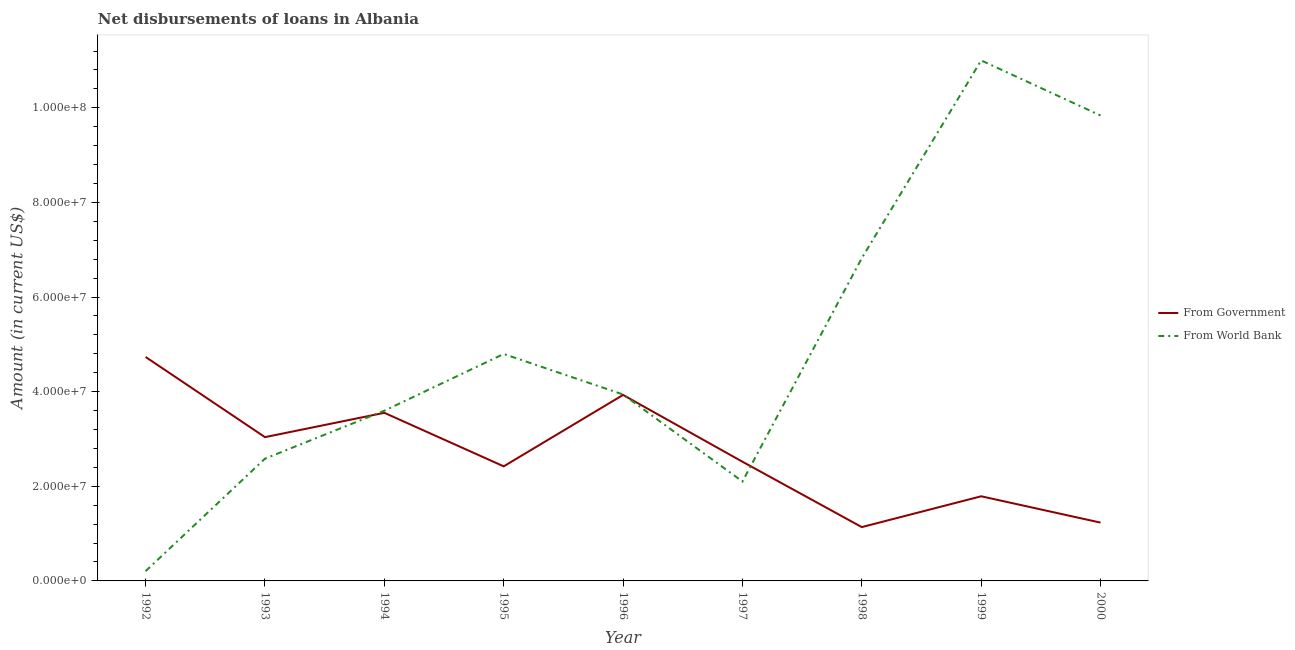What is the net disbursements of loan from government in 1995?
Your answer should be compact. 2.42e+07. Across all years, what is the maximum net disbursements of loan from government?
Ensure brevity in your answer.  4.73e+07. Across all years, what is the minimum net disbursements of loan from world bank?
Make the answer very short. 2.06e+06. In which year was the net disbursements of loan from government maximum?
Provide a short and direct response. 1992. In which year was the net disbursements of loan from world bank minimum?
Provide a short and direct response. 1992. What is the total net disbursements of loan from government in the graph?
Your answer should be very brief. 2.44e+08. What is the difference between the net disbursements of loan from world bank in 1992 and that in 1999?
Your answer should be compact. -1.08e+08. What is the difference between the net disbursements of loan from government in 1994 and the net disbursements of loan from world bank in 1998?
Offer a terse response. -3.27e+07. What is the average net disbursements of loan from world bank per year?
Ensure brevity in your answer.  4.99e+07. In the year 1992, what is the difference between the net disbursements of loan from government and net disbursements of loan from world bank?
Ensure brevity in your answer.  4.53e+07. In how many years, is the net disbursements of loan from world bank greater than 84000000 US$?
Make the answer very short. 2. What is the ratio of the net disbursements of loan from world bank in 1998 to that in 2000?
Ensure brevity in your answer.  0.69. What is the difference between the highest and the second highest net disbursements of loan from world bank?
Ensure brevity in your answer.  1.16e+07. What is the difference between the highest and the lowest net disbursements of loan from government?
Provide a succinct answer. 3.60e+07. In how many years, is the net disbursements of loan from government greater than the average net disbursements of loan from government taken over all years?
Make the answer very short. 4. Does the net disbursements of loan from world bank monotonically increase over the years?
Make the answer very short. No. Is the net disbursements of loan from government strictly less than the net disbursements of loan from world bank over the years?
Ensure brevity in your answer.  No. How many lines are there?
Your answer should be compact. 2. Are the values on the major ticks of Y-axis written in scientific E-notation?
Your response must be concise. Yes. Does the graph contain any zero values?
Your answer should be very brief. No. Does the graph contain grids?
Your answer should be compact. No. What is the title of the graph?
Keep it short and to the point. Net disbursements of loans in Albania. Does "Tetanus" appear as one of the legend labels in the graph?
Give a very brief answer. No. What is the label or title of the X-axis?
Your response must be concise. Year. What is the label or title of the Y-axis?
Make the answer very short. Amount (in current US$). What is the Amount (in current US$) of From Government in 1992?
Offer a terse response. 4.73e+07. What is the Amount (in current US$) in From World Bank in 1992?
Your response must be concise. 2.06e+06. What is the Amount (in current US$) in From Government in 1993?
Provide a short and direct response. 3.04e+07. What is the Amount (in current US$) of From World Bank in 1993?
Give a very brief answer. 2.58e+07. What is the Amount (in current US$) in From Government in 1994?
Offer a terse response. 3.55e+07. What is the Amount (in current US$) in From World Bank in 1994?
Give a very brief answer. 3.60e+07. What is the Amount (in current US$) of From Government in 1995?
Keep it short and to the point. 2.42e+07. What is the Amount (in current US$) in From World Bank in 1995?
Your response must be concise. 4.80e+07. What is the Amount (in current US$) in From Government in 1996?
Your answer should be compact. 3.93e+07. What is the Amount (in current US$) in From World Bank in 1996?
Your response must be concise. 3.94e+07. What is the Amount (in current US$) in From Government in 1997?
Make the answer very short. 2.52e+07. What is the Amount (in current US$) in From World Bank in 1997?
Ensure brevity in your answer.  2.10e+07. What is the Amount (in current US$) of From Government in 1998?
Provide a succinct answer. 1.14e+07. What is the Amount (in current US$) of From World Bank in 1998?
Your answer should be very brief. 6.82e+07. What is the Amount (in current US$) in From Government in 1999?
Keep it short and to the point. 1.79e+07. What is the Amount (in current US$) in From World Bank in 1999?
Your response must be concise. 1.10e+08. What is the Amount (in current US$) of From Government in 2000?
Ensure brevity in your answer.  1.23e+07. What is the Amount (in current US$) in From World Bank in 2000?
Offer a terse response. 9.84e+07. Across all years, what is the maximum Amount (in current US$) in From Government?
Provide a short and direct response. 4.73e+07. Across all years, what is the maximum Amount (in current US$) of From World Bank?
Make the answer very short. 1.10e+08. Across all years, what is the minimum Amount (in current US$) of From Government?
Make the answer very short. 1.14e+07. Across all years, what is the minimum Amount (in current US$) in From World Bank?
Give a very brief answer. 2.06e+06. What is the total Amount (in current US$) of From Government in the graph?
Provide a succinct answer. 2.44e+08. What is the total Amount (in current US$) of From World Bank in the graph?
Keep it short and to the point. 4.49e+08. What is the difference between the Amount (in current US$) in From Government in 1992 and that in 1993?
Ensure brevity in your answer.  1.69e+07. What is the difference between the Amount (in current US$) in From World Bank in 1992 and that in 1993?
Offer a terse response. -2.38e+07. What is the difference between the Amount (in current US$) of From Government in 1992 and that in 1994?
Give a very brief answer. 1.18e+07. What is the difference between the Amount (in current US$) of From World Bank in 1992 and that in 1994?
Make the answer very short. -3.39e+07. What is the difference between the Amount (in current US$) in From Government in 1992 and that in 1995?
Provide a succinct answer. 2.31e+07. What is the difference between the Amount (in current US$) in From World Bank in 1992 and that in 1995?
Your answer should be compact. -4.59e+07. What is the difference between the Amount (in current US$) in From Government in 1992 and that in 1996?
Offer a very short reply. 8.02e+06. What is the difference between the Amount (in current US$) of From World Bank in 1992 and that in 1996?
Your response must be concise. -3.73e+07. What is the difference between the Amount (in current US$) in From Government in 1992 and that in 1997?
Your response must be concise. 2.21e+07. What is the difference between the Amount (in current US$) in From World Bank in 1992 and that in 1997?
Make the answer very short. -1.90e+07. What is the difference between the Amount (in current US$) of From Government in 1992 and that in 1998?
Give a very brief answer. 3.60e+07. What is the difference between the Amount (in current US$) of From World Bank in 1992 and that in 1998?
Your response must be concise. -6.62e+07. What is the difference between the Amount (in current US$) of From Government in 1992 and that in 1999?
Make the answer very short. 2.94e+07. What is the difference between the Amount (in current US$) in From World Bank in 1992 and that in 1999?
Keep it short and to the point. -1.08e+08. What is the difference between the Amount (in current US$) in From Government in 1992 and that in 2000?
Provide a succinct answer. 3.50e+07. What is the difference between the Amount (in current US$) of From World Bank in 1992 and that in 2000?
Provide a short and direct response. -9.63e+07. What is the difference between the Amount (in current US$) of From Government in 1993 and that in 1994?
Offer a very short reply. -5.14e+06. What is the difference between the Amount (in current US$) of From World Bank in 1993 and that in 1994?
Offer a terse response. -1.01e+07. What is the difference between the Amount (in current US$) of From Government in 1993 and that in 1995?
Offer a terse response. 6.17e+06. What is the difference between the Amount (in current US$) of From World Bank in 1993 and that in 1995?
Your response must be concise. -2.21e+07. What is the difference between the Amount (in current US$) in From Government in 1993 and that in 1996?
Offer a very short reply. -8.92e+06. What is the difference between the Amount (in current US$) of From World Bank in 1993 and that in 1996?
Your answer should be very brief. -1.36e+07. What is the difference between the Amount (in current US$) of From Government in 1993 and that in 1997?
Your answer should be very brief. 5.19e+06. What is the difference between the Amount (in current US$) in From World Bank in 1993 and that in 1997?
Keep it short and to the point. 4.82e+06. What is the difference between the Amount (in current US$) in From Government in 1993 and that in 1998?
Make the answer very short. 1.90e+07. What is the difference between the Amount (in current US$) in From World Bank in 1993 and that in 1998?
Give a very brief answer. -4.24e+07. What is the difference between the Amount (in current US$) of From Government in 1993 and that in 1999?
Offer a very short reply. 1.25e+07. What is the difference between the Amount (in current US$) in From World Bank in 1993 and that in 1999?
Provide a succinct answer. -8.42e+07. What is the difference between the Amount (in current US$) in From Government in 1993 and that in 2000?
Your response must be concise. 1.81e+07. What is the difference between the Amount (in current US$) in From World Bank in 1993 and that in 2000?
Ensure brevity in your answer.  -7.25e+07. What is the difference between the Amount (in current US$) in From Government in 1994 and that in 1995?
Offer a very short reply. 1.13e+07. What is the difference between the Amount (in current US$) in From World Bank in 1994 and that in 1995?
Provide a short and direct response. -1.20e+07. What is the difference between the Amount (in current US$) in From Government in 1994 and that in 1996?
Your answer should be very brief. -3.78e+06. What is the difference between the Amount (in current US$) in From World Bank in 1994 and that in 1996?
Keep it short and to the point. -3.43e+06. What is the difference between the Amount (in current US$) of From Government in 1994 and that in 1997?
Keep it short and to the point. 1.03e+07. What is the difference between the Amount (in current US$) in From World Bank in 1994 and that in 1997?
Make the answer very short. 1.50e+07. What is the difference between the Amount (in current US$) of From Government in 1994 and that in 1998?
Give a very brief answer. 2.42e+07. What is the difference between the Amount (in current US$) in From World Bank in 1994 and that in 1998?
Ensure brevity in your answer.  -3.23e+07. What is the difference between the Amount (in current US$) in From Government in 1994 and that in 1999?
Your response must be concise. 1.76e+07. What is the difference between the Amount (in current US$) in From World Bank in 1994 and that in 1999?
Give a very brief answer. -7.40e+07. What is the difference between the Amount (in current US$) in From Government in 1994 and that in 2000?
Give a very brief answer. 2.32e+07. What is the difference between the Amount (in current US$) of From World Bank in 1994 and that in 2000?
Provide a short and direct response. -6.24e+07. What is the difference between the Amount (in current US$) of From Government in 1995 and that in 1996?
Provide a succinct answer. -1.51e+07. What is the difference between the Amount (in current US$) of From World Bank in 1995 and that in 1996?
Offer a very short reply. 8.56e+06. What is the difference between the Amount (in current US$) in From Government in 1995 and that in 1997?
Your answer should be compact. -9.78e+05. What is the difference between the Amount (in current US$) of From World Bank in 1995 and that in 1997?
Offer a terse response. 2.70e+07. What is the difference between the Amount (in current US$) of From Government in 1995 and that in 1998?
Offer a very short reply. 1.28e+07. What is the difference between the Amount (in current US$) in From World Bank in 1995 and that in 1998?
Keep it short and to the point. -2.03e+07. What is the difference between the Amount (in current US$) of From Government in 1995 and that in 1999?
Your answer should be compact. 6.33e+06. What is the difference between the Amount (in current US$) of From World Bank in 1995 and that in 1999?
Your answer should be very brief. -6.20e+07. What is the difference between the Amount (in current US$) in From Government in 1995 and that in 2000?
Provide a succinct answer. 1.19e+07. What is the difference between the Amount (in current US$) of From World Bank in 1995 and that in 2000?
Give a very brief answer. -5.04e+07. What is the difference between the Amount (in current US$) of From Government in 1996 and that in 1997?
Provide a succinct answer. 1.41e+07. What is the difference between the Amount (in current US$) of From World Bank in 1996 and that in 1997?
Provide a succinct answer. 1.84e+07. What is the difference between the Amount (in current US$) in From Government in 1996 and that in 1998?
Provide a short and direct response. 2.79e+07. What is the difference between the Amount (in current US$) of From World Bank in 1996 and that in 1998?
Keep it short and to the point. -2.88e+07. What is the difference between the Amount (in current US$) of From Government in 1996 and that in 1999?
Offer a terse response. 2.14e+07. What is the difference between the Amount (in current US$) of From World Bank in 1996 and that in 1999?
Offer a very short reply. -7.06e+07. What is the difference between the Amount (in current US$) in From Government in 1996 and that in 2000?
Your response must be concise. 2.70e+07. What is the difference between the Amount (in current US$) in From World Bank in 1996 and that in 2000?
Make the answer very short. -5.90e+07. What is the difference between the Amount (in current US$) in From Government in 1997 and that in 1998?
Your response must be concise. 1.38e+07. What is the difference between the Amount (in current US$) in From World Bank in 1997 and that in 1998?
Your answer should be compact. -4.72e+07. What is the difference between the Amount (in current US$) of From Government in 1997 and that in 1999?
Your answer should be very brief. 7.31e+06. What is the difference between the Amount (in current US$) of From World Bank in 1997 and that in 1999?
Give a very brief answer. -8.90e+07. What is the difference between the Amount (in current US$) of From Government in 1997 and that in 2000?
Provide a succinct answer. 1.29e+07. What is the difference between the Amount (in current US$) of From World Bank in 1997 and that in 2000?
Offer a very short reply. -7.74e+07. What is the difference between the Amount (in current US$) in From Government in 1998 and that in 1999?
Offer a terse response. -6.52e+06. What is the difference between the Amount (in current US$) of From World Bank in 1998 and that in 1999?
Keep it short and to the point. -4.18e+07. What is the difference between the Amount (in current US$) of From Government in 1998 and that in 2000?
Offer a terse response. -9.48e+05. What is the difference between the Amount (in current US$) of From World Bank in 1998 and that in 2000?
Your answer should be compact. -3.01e+07. What is the difference between the Amount (in current US$) of From Government in 1999 and that in 2000?
Make the answer very short. 5.57e+06. What is the difference between the Amount (in current US$) of From World Bank in 1999 and that in 2000?
Offer a very short reply. 1.16e+07. What is the difference between the Amount (in current US$) of From Government in 1992 and the Amount (in current US$) of From World Bank in 1993?
Keep it short and to the point. 2.15e+07. What is the difference between the Amount (in current US$) in From Government in 1992 and the Amount (in current US$) in From World Bank in 1994?
Your answer should be compact. 1.14e+07. What is the difference between the Amount (in current US$) of From Government in 1992 and the Amount (in current US$) of From World Bank in 1995?
Your answer should be very brief. -6.33e+05. What is the difference between the Amount (in current US$) in From Government in 1992 and the Amount (in current US$) in From World Bank in 1996?
Offer a terse response. 7.93e+06. What is the difference between the Amount (in current US$) of From Government in 1992 and the Amount (in current US$) of From World Bank in 1997?
Your answer should be very brief. 2.63e+07. What is the difference between the Amount (in current US$) of From Government in 1992 and the Amount (in current US$) of From World Bank in 1998?
Give a very brief answer. -2.09e+07. What is the difference between the Amount (in current US$) of From Government in 1992 and the Amount (in current US$) of From World Bank in 1999?
Your answer should be very brief. -6.27e+07. What is the difference between the Amount (in current US$) in From Government in 1992 and the Amount (in current US$) in From World Bank in 2000?
Provide a short and direct response. -5.10e+07. What is the difference between the Amount (in current US$) in From Government in 1993 and the Amount (in current US$) in From World Bank in 1994?
Ensure brevity in your answer.  -5.58e+06. What is the difference between the Amount (in current US$) in From Government in 1993 and the Amount (in current US$) in From World Bank in 1995?
Keep it short and to the point. -1.76e+07. What is the difference between the Amount (in current US$) in From Government in 1993 and the Amount (in current US$) in From World Bank in 1996?
Keep it short and to the point. -9.02e+06. What is the difference between the Amount (in current US$) of From Government in 1993 and the Amount (in current US$) of From World Bank in 1997?
Offer a very short reply. 9.38e+06. What is the difference between the Amount (in current US$) in From Government in 1993 and the Amount (in current US$) in From World Bank in 1998?
Offer a very short reply. -3.78e+07. What is the difference between the Amount (in current US$) of From Government in 1993 and the Amount (in current US$) of From World Bank in 1999?
Make the answer very short. -7.96e+07. What is the difference between the Amount (in current US$) of From Government in 1993 and the Amount (in current US$) of From World Bank in 2000?
Provide a short and direct response. -6.80e+07. What is the difference between the Amount (in current US$) in From Government in 1994 and the Amount (in current US$) in From World Bank in 1995?
Keep it short and to the point. -1.24e+07. What is the difference between the Amount (in current US$) of From Government in 1994 and the Amount (in current US$) of From World Bank in 1996?
Ensure brevity in your answer.  -3.88e+06. What is the difference between the Amount (in current US$) of From Government in 1994 and the Amount (in current US$) of From World Bank in 1997?
Give a very brief answer. 1.45e+07. What is the difference between the Amount (in current US$) of From Government in 1994 and the Amount (in current US$) of From World Bank in 1998?
Your response must be concise. -3.27e+07. What is the difference between the Amount (in current US$) in From Government in 1994 and the Amount (in current US$) in From World Bank in 1999?
Offer a terse response. -7.45e+07. What is the difference between the Amount (in current US$) of From Government in 1994 and the Amount (in current US$) of From World Bank in 2000?
Keep it short and to the point. -6.28e+07. What is the difference between the Amount (in current US$) of From Government in 1995 and the Amount (in current US$) of From World Bank in 1996?
Offer a very short reply. -1.52e+07. What is the difference between the Amount (in current US$) in From Government in 1995 and the Amount (in current US$) in From World Bank in 1997?
Your answer should be compact. 3.20e+06. What is the difference between the Amount (in current US$) in From Government in 1995 and the Amount (in current US$) in From World Bank in 1998?
Your response must be concise. -4.40e+07. What is the difference between the Amount (in current US$) in From Government in 1995 and the Amount (in current US$) in From World Bank in 1999?
Give a very brief answer. -8.58e+07. What is the difference between the Amount (in current US$) of From Government in 1995 and the Amount (in current US$) of From World Bank in 2000?
Your answer should be compact. -7.42e+07. What is the difference between the Amount (in current US$) of From Government in 1996 and the Amount (in current US$) of From World Bank in 1997?
Offer a terse response. 1.83e+07. What is the difference between the Amount (in current US$) of From Government in 1996 and the Amount (in current US$) of From World Bank in 1998?
Offer a very short reply. -2.89e+07. What is the difference between the Amount (in current US$) in From Government in 1996 and the Amount (in current US$) in From World Bank in 1999?
Your answer should be compact. -7.07e+07. What is the difference between the Amount (in current US$) of From Government in 1996 and the Amount (in current US$) of From World Bank in 2000?
Give a very brief answer. -5.91e+07. What is the difference between the Amount (in current US$) of From Government in 1997 and the Amount (in current US$) of From World Bank in 1998?
Offer a terse response. -4.30e+07. What is the difference between the Amount (in current US$) of From Government in 1997 and the Amount (in current US$) of From World Bank in 1999?
Ensure brevity in your answer.  -8.48e+07. What is the difference between the Amount (in current US$) in From Government in 1997 and the Amount (in current US$) in From World Bank in 2000?
Make the answer very short. -7.32e+07. What is the difference between the Amount (in current US$) of From Government in 1998 and the Amount (in current US$) of From World Bank in 1999?
Keep it short and to the point. -9.86e+07. What is the difference between the Amount (in current US$) in From Government in 1998 and the Amount (in current US$) in From World Bank in 2000?
Your answer should be compact. -8.70e+07. What is the difference between the Amount (in current US$) in From Government in 1999 and the Amount (in current US$) in From World Bank in 2000?
Ensure brevity in your answer.  -8.05e+07. What is the average Amount (in current US$) of From Government per year?
Your response must be concise. 2.71e+07. What is the average Amount (in current US$) of From World Bank per year?
Keep it short and to the point. 4.99e+07. In the year 1992, what is the difference between the Amount (in current US$) in From Government and Amount (in current US$) in From World Bank?
Provide a short and direct response. 4.53e+07. In the year 1993, what is the difference between the Amount (in current US$) of From Government and Amount (in current US$) of From World Bank?
Keep it short and to the point. 4.55e+06. In the year 1994, what is the difference between the Amount (in current US$) of From Government and Amount (in current US$) of From World Bank?
Keep it short and to the point. -4.43e+05. In the year 1995, what is the difference between the Amount (in current US$) of From Government and Amount (in current US$) of From World Bank?
Provide a short and direct response. -2.38e+07. In the year 1996, what is the difference between the Amount (in current US$) of From Government and Amount (in current US$) of From World Bank?
Offer a very short reply. -9.50e+04. In the year 1997, what is the difference between the Amount (in current US$) of From Government and Amount (in current US$) of From World Bank?
Offer a very short reply. 4.18e+06. In the year 1998, what is the difference between the Amount (in current US$) of From Government and Amount (in current US$) of From World Bank?
Offer a terse response. -5.69e+07. In the year 1999, what is the difference between the Amount (in current US$) of From Government and Amount (in current US$) of From World Bank?
Provide a short and direct response. -9.21e+07. In the year 2000, what is the difference between the Amount (in current US$) in From Government and Amount (in current US$) in From World Bank?
Your response must be concise. -8.61e+07. What is the ratio of the Amount (in current US$) in From Government in 1992 to that in 1993?
Ensure brevity in your answer.  1.56. What is the ratio of the Amount (in current US$) of From World Bank in 1992 to that in 1993?
Your answer should be compact. 0.08. What is the ratio of the Amount (in current US$) in From Government in 1992 to that in 1994?
Your answer should be very brief. 1.33. What is the ratio of the Amount (in current US$) in From World Bank in 1992 to that in 1994?
Provide a short and direct response. 0.06. What is the ratio of the Amount (in current US$) in From Government in 1992 to that in 1995?
Your answer should be very brief. 1.95. What is the ratio of the Amount (in current US$) of From World Bank in 1992 to that in 1995?
Offer a terse response. 0.04. What is the ratio of the Amount (in current US$) in From Government in 1992 to that in 1996?
Offer a very short reply. 1.2. What is the ratio of the Amount (in current US$) in From World Bank in 1992 to that in 1996?
Keep it short and to the point. 0.05. What is the ratio of the Amount (in current US$) of From Government in 1992 to that in 1997?
Offer a very short reply. 1.88. What is the ratio of the Amount (in current US$) in From World Bank in 1992 to that in 1997?
Make the answer very short. 0.1. What is the ratio of the Amount (in current US$) in From Government in 1992 to that in 1998?
Your answer should be very brief. 4.16. What is the ratio of the Amount (in current US$) of From World Bank in 1992 to that in 1998?
Keep it short and to the point. 0.03. What is the ratio of the Amount (in current US$) of From Government in 1992 to that in 1999?
Your response must be concise. 2.65. What is the ratio of the Amount (in current US$) of From World Bank in 1992 to that in 1999?
Your response must be concise. 0.02. What is the ratio of the Amount (in current US$) in From Government in 1992 to that in 2000?
Offer a very short reply. 3.84. What is the ratio of the Amount (in current US$) in From World Bank in 1992 to that in 2000?
Your answer should be compact. 0.02. What is the ratio of the Amount (in current US$) in From Government in 1993 to that in 1994?
Your answer should be compact. 0.86. What is the ratio of the Amount (in current US$) of From World Bank in 1993 to that in 1994?
Ensure brevity in your answer.  0.72. What is the ratio of the Amount (in current US$) of From Government in 1993 to that in 1995?
Your answer should be very brief. 1.25. What is the ratio of the Amount (in current US$) of From World Bank in 1993 to that in 1995?
Your response must be concise. 0.54. What is the ratio of the Amount (in current US$) in From Government in 1993 to that in 1996?
Your answer should be very brief. 0.77. What is the ratio of the Amount (in current US$) in From World Bank in 1993 to that in 1996?
Your answer should be compact. 0.66. What is the ratio of the Amount (in current US$) in From Government in 1993 to that in 1997?
Make the answer very short. 1.21. What is the ratio of the Amount (in current US$) of From World Bank in 1993 to that in 1997?
Ensure brevity in your answer.  1.23. What is the ratio of the Amount (in current US$) of From Government in 1993 to that in 1998?
Keep it short and to the point. 2.67. What is the ratio of the Amount (in current US$) in From World Bank in 1993 to that in 1998?
Ensure brevity in your answer.  0.38. What is the ratio of the Amount (in current US$) in From Government in 1993 to that in 1999?
Provide a succinct answer. 1.7. What is the ratio of the Amount (in current US$) of From World Bank in 1993 to that in 1999?
Give a very brief answer. 0.23. What is the ratio of the Amount (in current US$) in From Government in 1993 to that in 2000?
Your answer should be very brief. 2.47. What is the ratio of the Amount (in current US$) of From World Bank in 1993 to that in 2000?
Your answer should be very brief. 0.26. What is the ratio of the Amount (in current US$) of From Government in 1994 to that in 1995?
Provide a succinct answer. 1.47. What is the ratio of the Amount (in current US$) of From Government in 1994 to that in 1996?
Provide a short and direct response. 0.9. What is the ratio of the Amount (in current US$) in From World Bank in 1994 to that in 1996?
Your answer should be compact. 0.91. What is the ratio of the Amount (in current US$) of From Government in 1994 to that in 1997?
Provide a short and direct response. 1.41. What is the ratio of the Amount (in current US$) of From World Bank in 1994 to that in 1997?
Provide a short and direct response. 1.71. What is the ratio of the Amount (in current US$) of From Government in 1994 to that in 1998?
Keep it short and to the point. 3.12. What is the ratio of the Amount (in current US$) in From World Bank in 1994 to that in 1998?
Your answer should be compact. 0.53. What is the ratio of the Amount (in current US$) in From Government in 1994 to that in 1999?
Your answer should be very brief. 1.99. What is the ratio of the Amount (in current US$) of From World Bank in 1994 to that in 1999?
Provide a short and direct response. 0.33. What is the ratio of the Amount (in current US$) of From Government in 1994 to that in 2000?
Offer a very short reply. 2.88. What is the ratio of the Amount (in current US$) in From World Bank in 1994 to that in 2000?
Keep it short and to the point. 0.37. What is the ratio of the Amount (in current US$) of From Government in 1995 to that in 1996?
Offer a terse response. 0.62. What is the ratio of the Amount (in current US$) in From World Bank in 1995 to that in 1996?
Make the answer very short. 1.22. What is the ratio of the Amount (in current US$) in From Government in 1995 to that in 1997?
Make the answer very short. 0.96. What is the ratio of the Amount (in current US$) of From World Bank in 1995 to that in 1997?
Offer a terse response. 2.28. What is the ratio of the Amount (in current US$) of From Government in 1995 to that in 1998?
Provide a succinct answer. 2.13. What is the ratio of the Amount (in current US$) in From World Bank in 1995 to that in 1998?
Your answer should be compact. 0.7. What is the ratio of the Amount (in current US$) of From Government in 1995 to that in 1999?
Your answer should be very brief. 1.35. What is the ratio of the Amount (in current US$) in From World Bank in 1995 to that in 1999?
Provide a short and direct response. 0.44. What is the ratio of the Amount (in current US$) of From Government in 1995 to that in 2000?
Your response must be concise. 1.97. What is the ratio of the Amount (in current US$) in From World Bank in 1995 to that in 2000?
Provide a succinct answer. 0.49. What is the ratio of the Amount (in current US$) of From Government in 1996 to that in 1997?
Make the answer very short. 1.56. What is the ratio of the Amount (in current US$) in From World Bank in 1996 to that in 1997?
Provide a short and direct response. 1.88. What is the ratio of the Amount (in current US$) of From Government in 1996 to that in 1998?
Your answer should be very brief. 3.46. What is the ratio of the Amount (in current US$) in From World Bank in 1996 to that in 1998?
Give a very brief answer. 0.58. What is the ratio of the Amount (in current US$) in From Government in 1996 to that in 1999?
Provide a succinct answer. 2.2. What is the ratio of the Amount (in current US$) of From World Bank in 1996 to that in 1999?
Offer a terse response. 0.36. What is the ratio of the Amount (in current US$) of From Government in 1996 to that in 2000?
Keep it short and to the point. 3.19. What is the ratio of the Amount (in current US$) of From World Bank in 1996 to that in 2000?
Provide a succinct answer. 0.4. What is the ratio of the Amount (in current US$) in From Government in 1997 to that in 1998?
Offer a terse response. 2.21. What is the ratio of the Amount (in current US$) in From World Bank in 1997 to that in 1998?
Your answer should be very brief. 0.31. What is the ratio of the Amount (in current US$) of From Government in 1997 to that in 1999?
Your response must be concise. 1.41. What is the ratio of the Amount (in current US$) of From World Bank in 1997 to that in 1999?
Ensure brevity in your answer.  0.19. What is the ratio of the Amount (in current US$) of From Government in 1997 to that in 2000?
Keep it short and to the point. 2.04. What is the ratio of the Amount (in current US$) in From World Bank in 1997 to that in 2000?
Your answer should be very brief. 0.21. What is the ratio of the Amount (in current US$) of From Government in 1998 to that in 1999?
Make the answer very short. 0.64. What is the ratio of the Amount (in current US$) of From World Bank in 1998 to that in 1999?
Keep it short and to the point. 0.62. What is the ratio of the Amount (in current US$) in From Government in 1998 to that in 2000?
Provide a succinct answer. 0.92. What is the ratio of the Amount (in current US$) of From World Bank in 1998 to that in 2000?
Provide a short and direct response. 0.69. What is the ratio of the Amount (in current US$) of From Government in 1999 to that in 2000?
Provide a succinct answer. 1.45. What is the ratio of the Amount (in current US$) in From World Bank in 1999 to that in 2000?
Your answer should be very brief. 1.12. What is the difference between the highest and the second highest Amount (in current US$) of From Government?
Provide a succinct answer. 8.02e+06. What is the difference between the highest and the second highest Amount (in current US$) of From World Bank?
Keep it short and to the point. 1.16e+07. What is the difference between the highest and the lowest Amount (in current US$) in From Government?
Your answer should be compact. 3.60e+07. What is the difference between the highest and the lowest Amount (in current US$) of From World Bank?
Offer a terse response. 1.08e+08. 